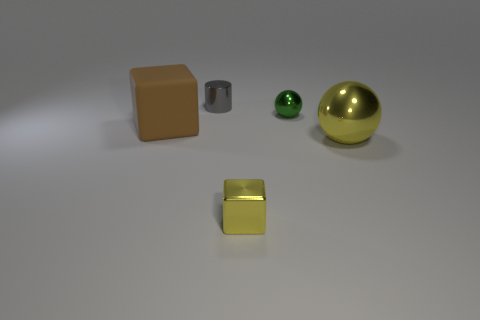How many blocks are the same color as the large ball?
Offer a terse response. 1. Is the number of shiny objects that are to the right of the yellow metal ball less than the number of large matte cubes?
Your response must be concise. Yes. Does the small yellow thing have the same shape as the big metallic object?
Offer a terse response. No. There is a cube that is on the right side of the big brown rubber cube; what size is it?
Provide a short and direct response. Small. There is a yellow cube that is made of the same material as the tiny sphere; what is its size?
Your answer should be very brief. Small. Are there fewer large purple metal objects than cubes?
Your answer should be very brief. Yes. What is the material of the cube that is the same size as the yellow sphere?
Your response must be concise. Rubber. Is the number of tiny gray shiny cylinders greater than the number of small red matte balls?
Give a very brief answer. Yes. How many other objects are there of the same color as the rubber cube?
Your answer should be very brief. 0. How many small shiny things are in front of the shiny cylinder and behind the big yellow metallic sphere?
Offer a terse response. 1. 